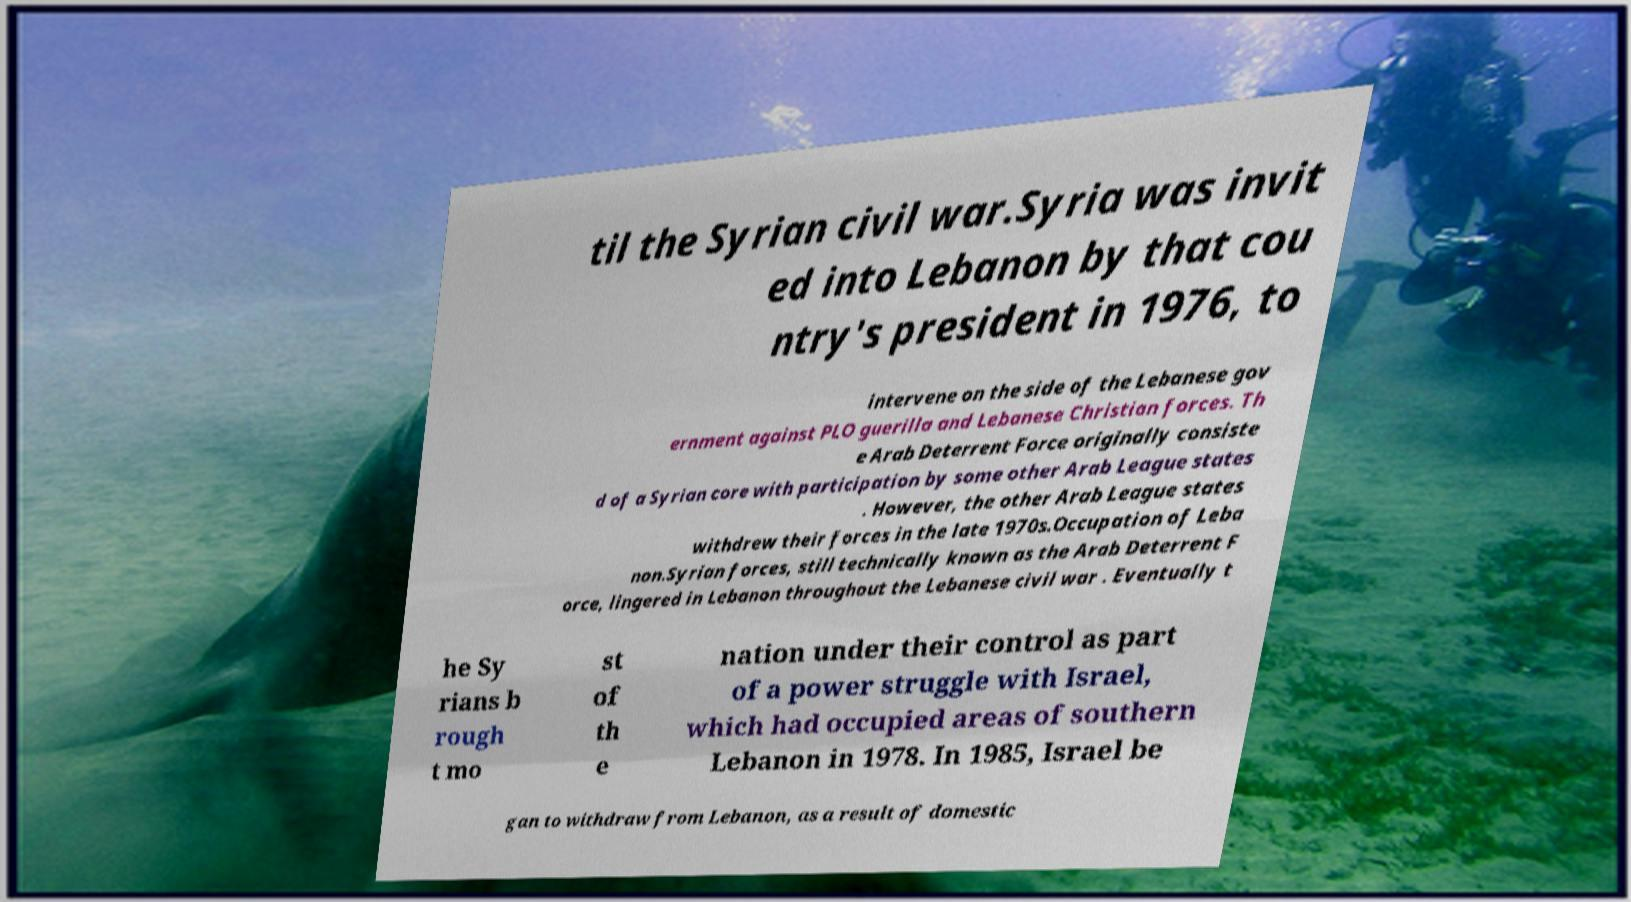Could you assist in decoding the text presented in this image and type it out clearly? til the Syrian civil war.Syria was invit ed into Lebanon by that cou ntry's president in 1976, to intervene on the side of the Lebanese gov ernment against PLO guerilla and Lebanese Christian forces. Th e Arab Deterrent Force originally consiste d of a Syrian core with participation by some other Arab League states . However, the other Arab League states withdrew their forces in the late 1970s.Occupation of Leba non.Syrian forces, still technically known as the Arab Deterrent F orce, lingered in Lebanon throughout the Lebanese civil war . Eventually t he Sy rians b rough t mo st of th e nation under their control as part of a power struggle with Israel, which had occupied areas of southern Lebanon in 1978. In 1985, Israel be gan to withdraw from Lebanon, as a result of domestic 